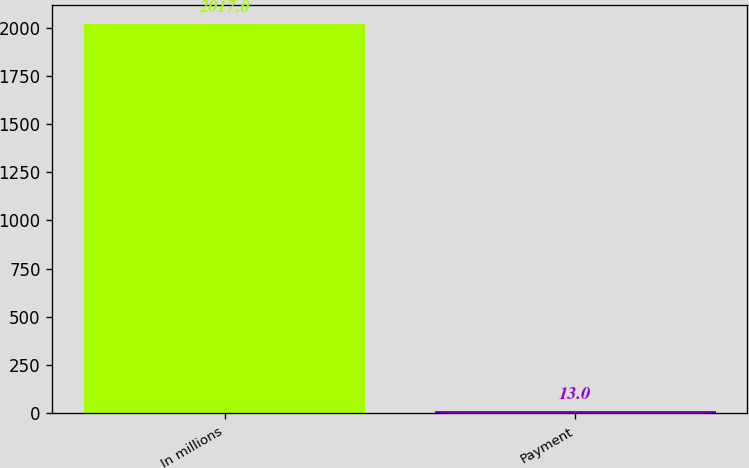Convert chart to OTSL. <chart><loc_0><loc_0><loc_500><loc_500><bar_chart><fcel>In millions<fcel>Payment<nl><fcel>2017<fcel>13<nl></chart> 